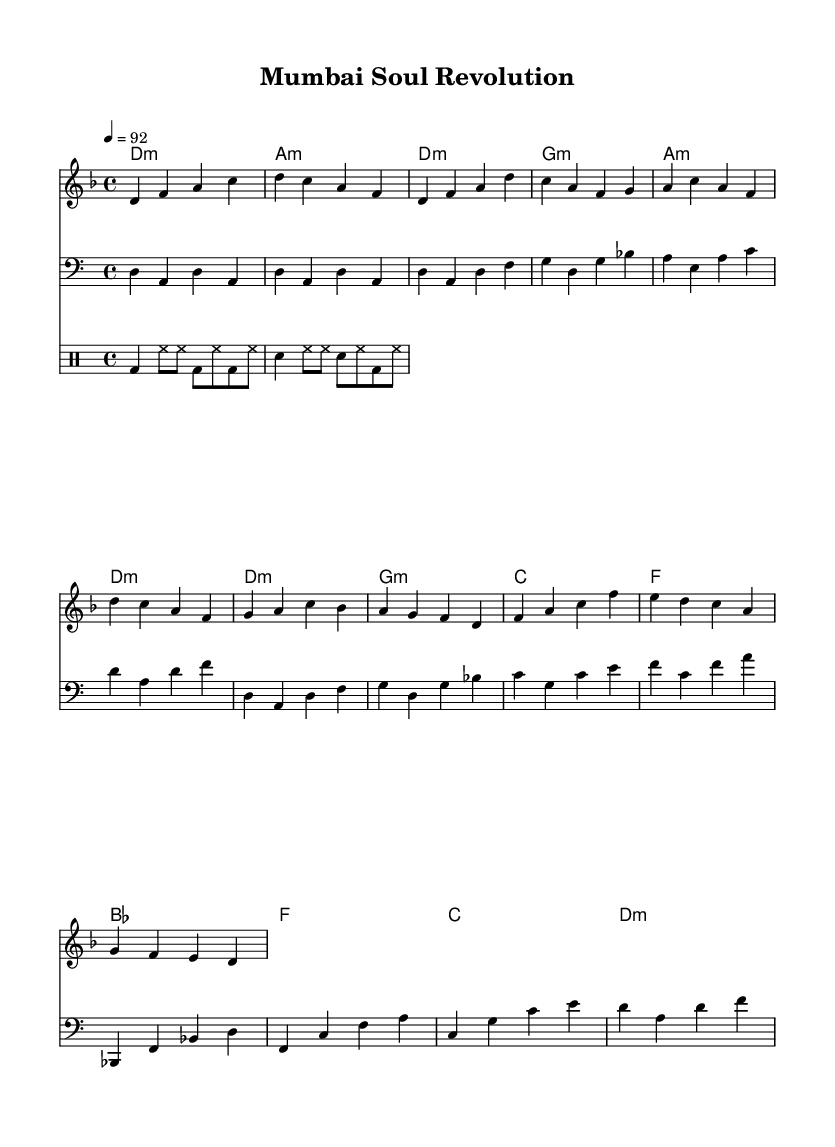What is the key signature of this music? The key signature indicated in the score is D minor, which has one flat (B flat). This can be identified by looking at the key signature at the beginning of the score.
Answer: D minor What is the time signature of the music? The time signature is 4/4, meaning there are four beats in each measure and a quarter note receives one beat. This is clearly noted at the start of the score.
Answer: 4/4 What is the tempo marking? The tempo marking is 92 beats per minute, which is indicated in the notation. This suggests a moderate pace for the music, and it usually guides performers on how fast to play.
Answer: 92 How many measures are in the chorus? The chorus consists of four measures, which can be verified by counting the measures in the section labeled for the chorus in the score.
Answer: Four measures What is the primary theme of the lyrics? The primary theme of the lyrics revolves around social justice and equality, as highlighted in the chorus "Soul of the city, hear our cry / Equality's flame will never die." This reflects a focus on important social issues.
Answer: Social justice and equality Which instrument plays the bass line? The bass line is intended to be played on a bass instrument, as indicated by the presence of a bass clef in the score for that particular staff.
Answer: Bass What type of rhythm does the drum part emphasize? The drum part emphasizes a steady, driving rhythm with the bass drum (bd) accentuated, along with hi-hats (hh) and snare drums (sn) providing a consistent backbeat throughout the measures. This is typical in soul music for creating a groovy foundation.
Answer: Steady driving rhythm 